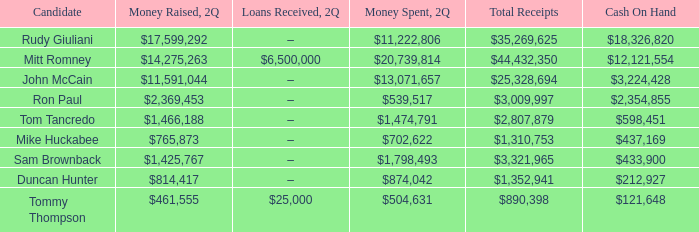What is the overall amount of money received by tom tancredo? $2,807,879. 